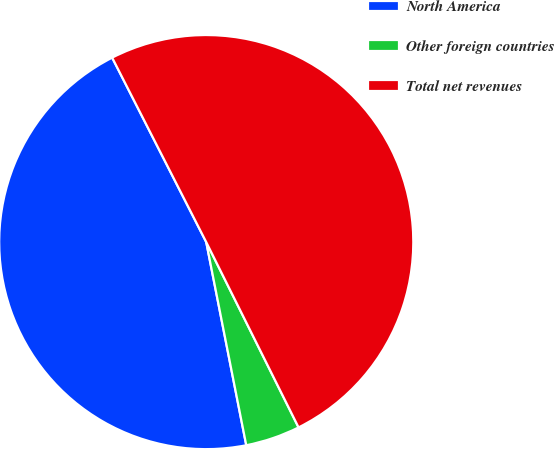<chart> <loc_0><loc_0><loc_500><loc_500><pie_chart><fcel>North America<fcel>Other foreign countries<fcel>Total net revenues<nl><fcel>45.59%<fcel>4.26%<fcel>50.15%<nl></chart> 